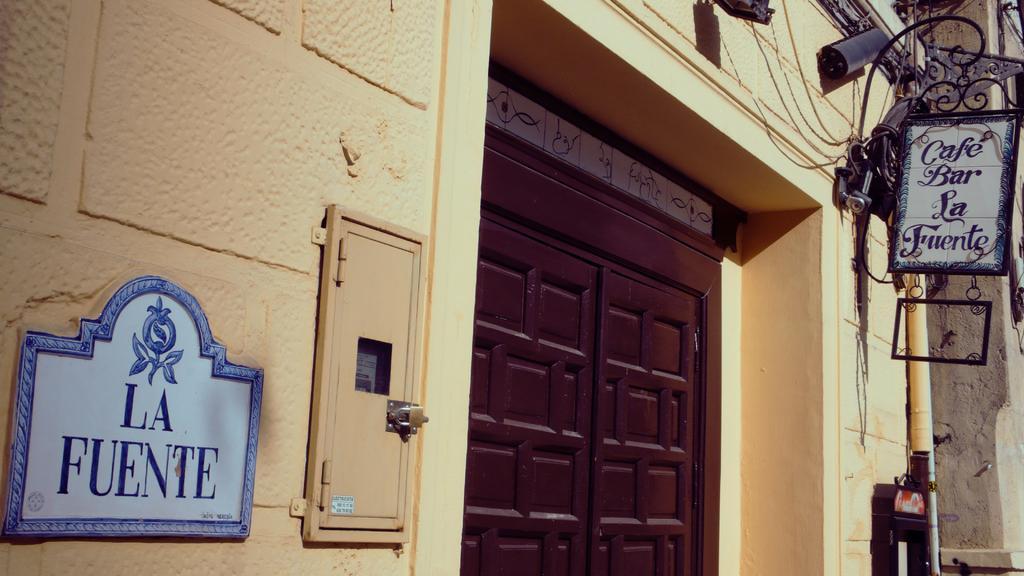Can you describe this image briefly? In this image we can see one cream color wall, one big brown color door, one blue color name plate attached to the wall, so many different objects attached to the wall, one pole, some wires and one iron name board attached to the wall. 